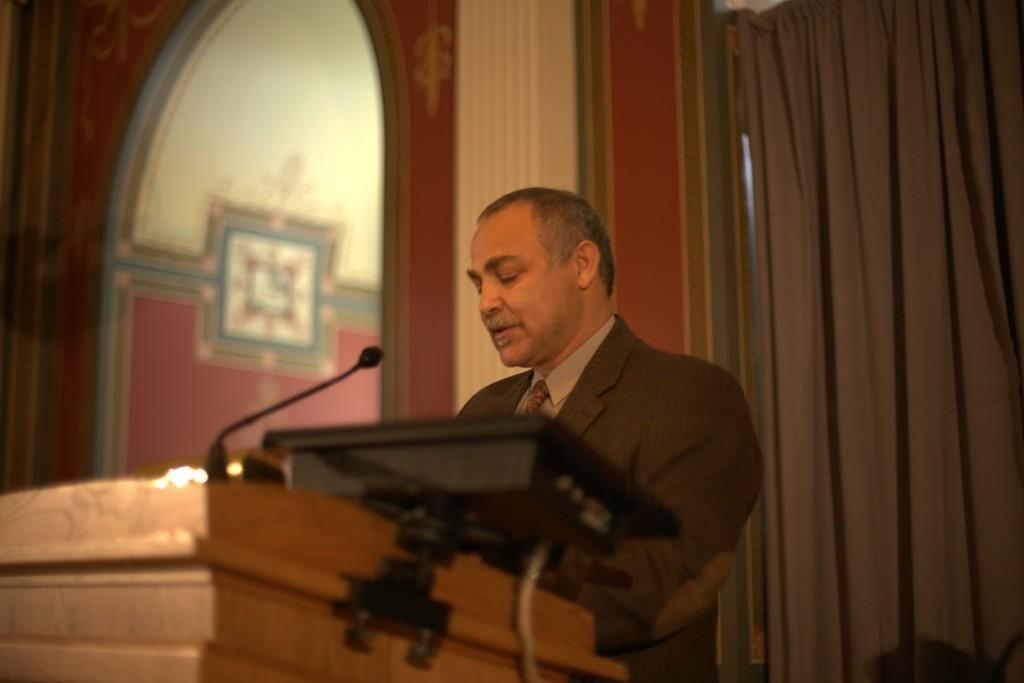How would you summarize this image in a sentence or two? In this image we can see a person, in front of him, there is a podium, mic, curtain, also we can see the wall, and there is an electronic gadget. 